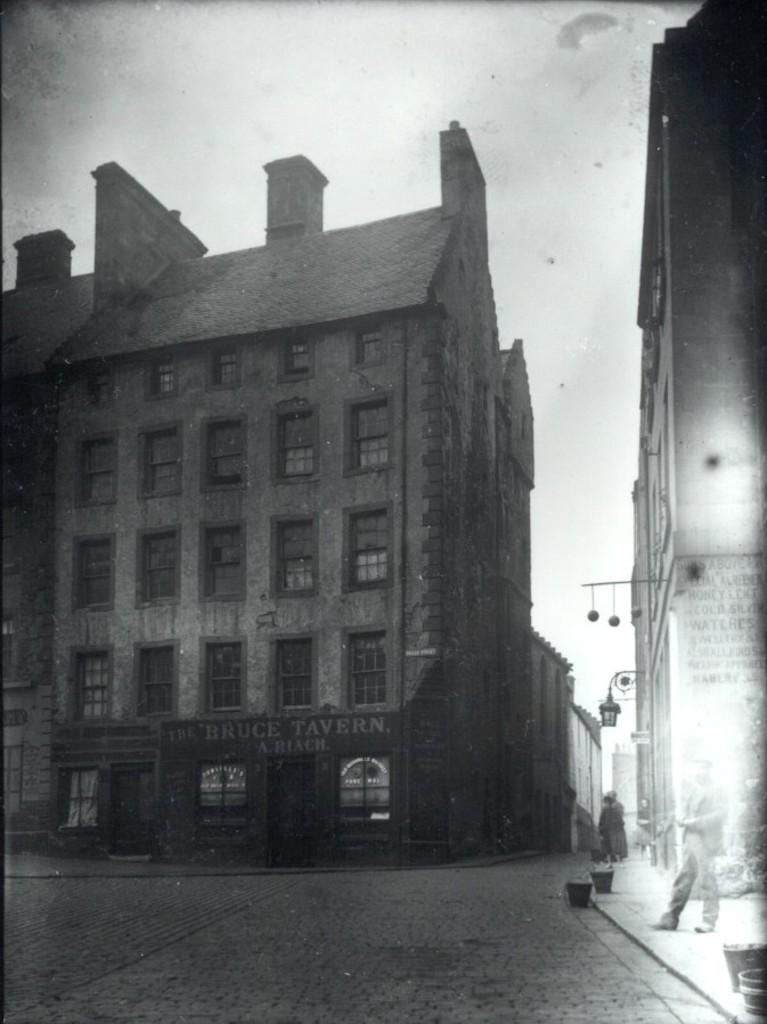What type of structures are visible in the image? There are buildings with windows in the image. What can be seen on the ground in the image? There is a road in the image. What is visible above the structures and road in the image? The sky is visible in the image. What type of cord is being used to connect the idea to the man in the image? There is no mention of an idea, a man, or a cord in the image. 